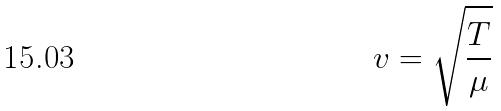<formula> <loc_0><loc_0><loc_500><loc_500>v = \sqrt { \frac { T } { \mu } }</formula> 